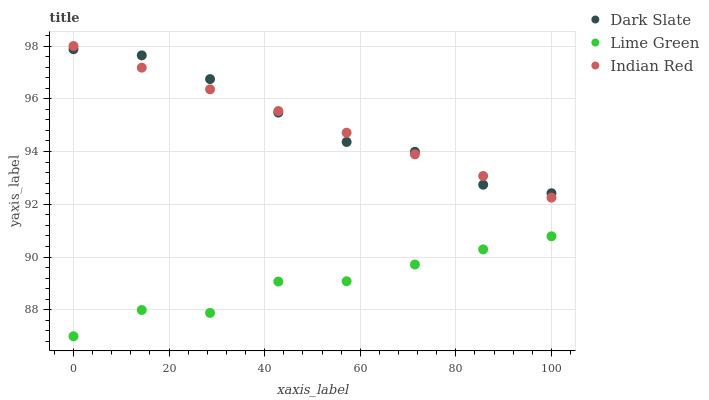Does Lime Green have the minimum area under the curve?
Answer yes or no. Yes. Does Dark Slate have the maximum area under the curve?
Answer yes or no. Yes. Does Indian Red have the minimum area under the curve?
Answer yes or no. No. Does Indian Red have the maximum area under the curve?
Answer yes or no. No. Is Indian Red the smoothest?
Answer yes or no. Yes. Is Lime Green the roughest?
Answer yes or no. Yes. Is Lime Green the smoothest?
Answer yes or no. No. Is Indian Red the roughest?
Answer yes or no. No. Does Lime Green have the lowest value?
Answer yes or no. Yes. Does Indian Red have the lowest value?
Answer yes or no. No. Does Indian Red have the highest value?
Answer yes or no. Yes. Does Lime Green have the highest value?
Answer yes or no. No. Is Lime Green less than Dark Slate?
Answer yes or no. Yes. Is Indian Red greater than Lime Green?
Answer yes or no. Yes. Does Indian Red intersect Dark Slate?
Answer yes or no. Yes. Is Indian Red less than Dark Slate?
Answer yes or no. No. Is Indian Red greater than Dark Slate?
Answer yes or no. No. Does Lime Green intersect Dark Slate?
Answer yes or no. No. 